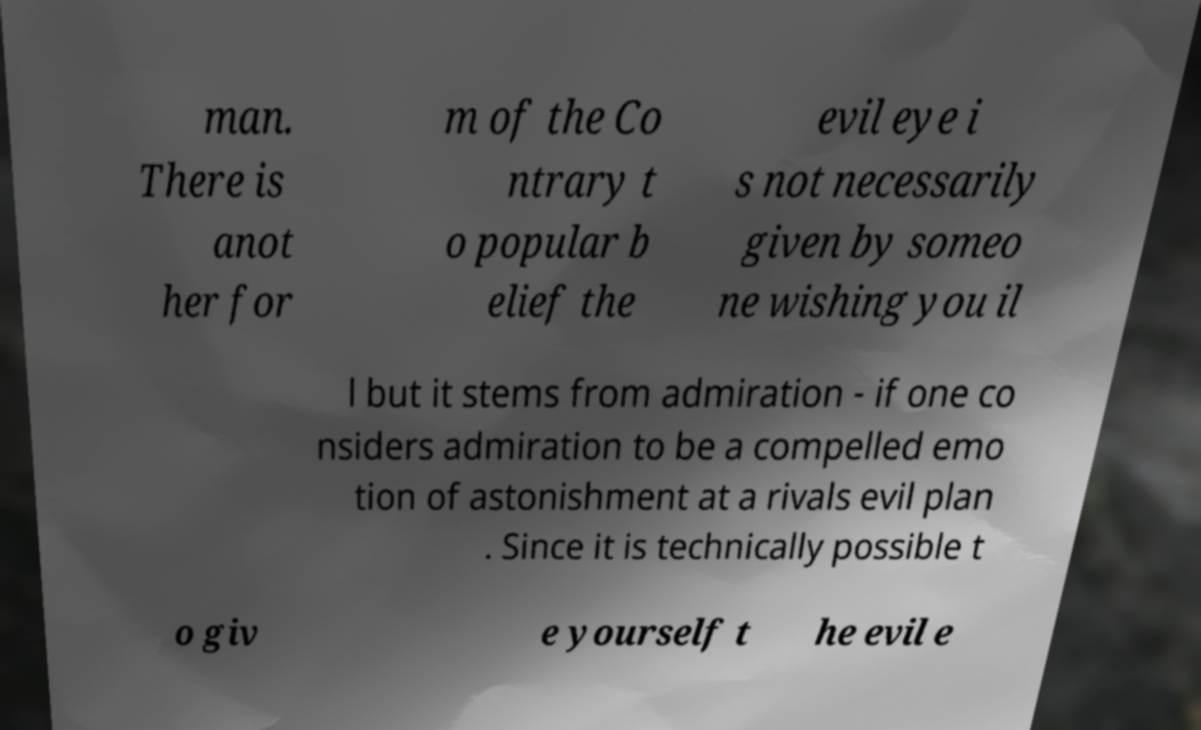Could you assist in decoding the text presented in this image and type it out clearly? man. There is anot her for m of the Co ntrary t o popular b elief the evil eye i s not necessarily given by someo ne wishing you il l but it stems from admiration - if one co nsiders admiration to be a compelled emo tion of astonishment at a rivals evil plan . Since it is technically possible t o giv e yourself t he evil e 